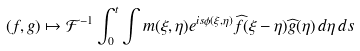<formula> <loc_0><loc_0><loc_500><loc_500>( f , g ) \mapsto \mathcal { F } ^ { - 1 } \int _ { 0 } ^ { t } \int m ( \xi , \eta ) e ^ { i s \phi ( \xi , \eta ) } \widehat { f } ( \xi - \eta ) \widehat { g } ( \eta ) \, d \eta \, d s</formula> 